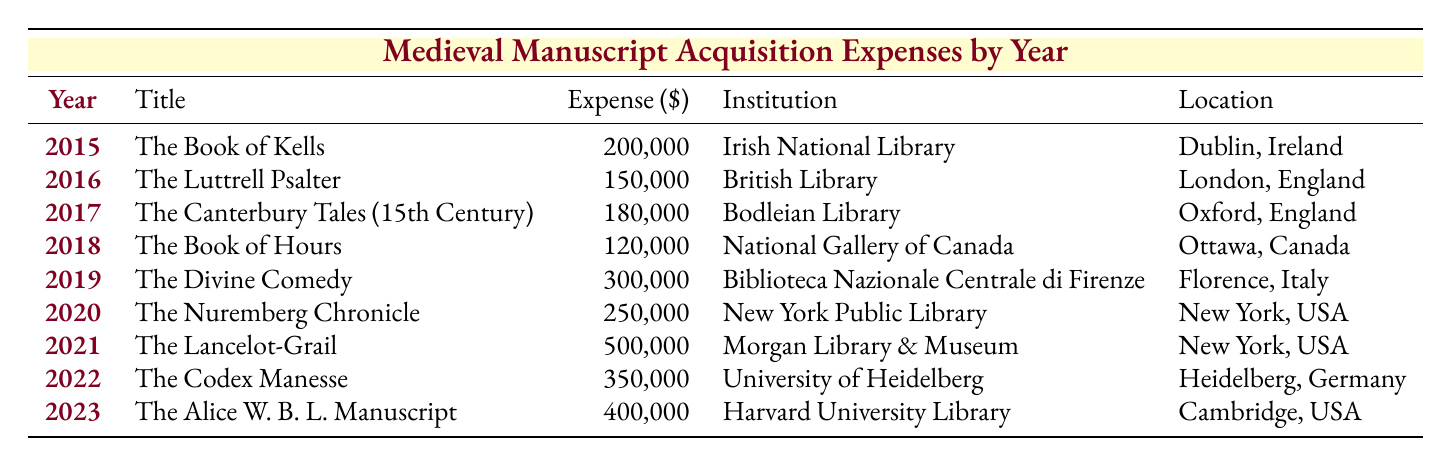What was the most expensive medieval manuscript acquisition in the table? The table lists the acquisitions along with their expenses. Scanning the "Expense (\$)" column, the highest value is **500,000**, corresponding to "The Lancelot-Grail" in 2021.
Answer: The Lancelot-Grail Which institution acquired "The Divine Comedy"? Looking up the title "The Divine Comedy" in the table, the corresponding institution listed is "Biblioteca Nazionale Centrale di Firenze."
Answer: Biblioteca Nazionale Centrale di Firenze What was the total expense for all acquisitions from 2015 to 2019? Adding the expenses for each of the years from 2015 to 2019: 200,000 + 150,000 + 180,000 + 120,000 + 300,000 = 950,000.
Answer: 950,000 Was the "The Book of Hours" more expensive than "The Canterbury Tales (15th Century)"? Comparing the expenses: "The Book of Hours" is **120,000** and "The Canterbury Tales (15th Century)" is **180,000**. Thus, it is not more expensive, as 120,000 < 180,000.
Answer: No What was the average acquisition expense for the years 2020 to 2023? First, sum the expenses for these years: 250,000 + 500,000 + 350,000 + 400,000 = 1,500,000. There are 4 years, so the average expense is 1,500,000 / 4 = 375,000.
Answer: 375,000 Which location had the highest acquisition expense and what was the amount? By checking the "Location" and corresponding "Expense" columns, "Morgan Library & Museum" in "New York, USA" has the highest expense, **500,000**.
Answer: 500,000 in New York, USA How much more expensive was "The Alice W. B. L. Manuscript" than "The Book of Hours"? Calculate the difference: The Alice W. B. L. Manuscript is **400,000** and The Book of Hours is **120,000**. Thus, 400,000 - 120,000 = 280,000.
Answer: 280,000 In which year was the least amount spent on manuscript acquisition? Checking the "Expense (\$)" column, the least amount is **120,000** for the year **2018**.
Answer: 2018 How many institutions are located in the USA based on the table? Scanning the "Institution" and "Location" columns, I find "New York Public Library," "Morgan Library & Museum," and "Harvard University Library," which are all in the USA. This gives a total of 3.
Answer: 3 